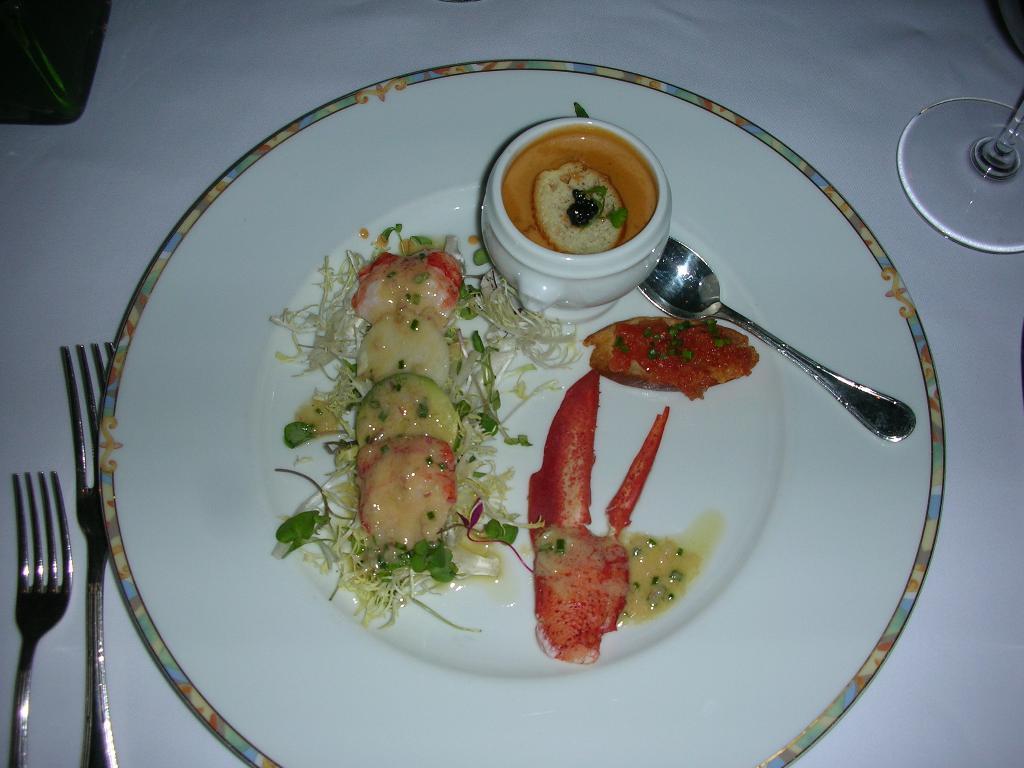Could you give a brief overview of what you see in this image? In the picture we can see some food item and spoon which are in white color plate and we can see two forks, glass which are on the surface of a table. 